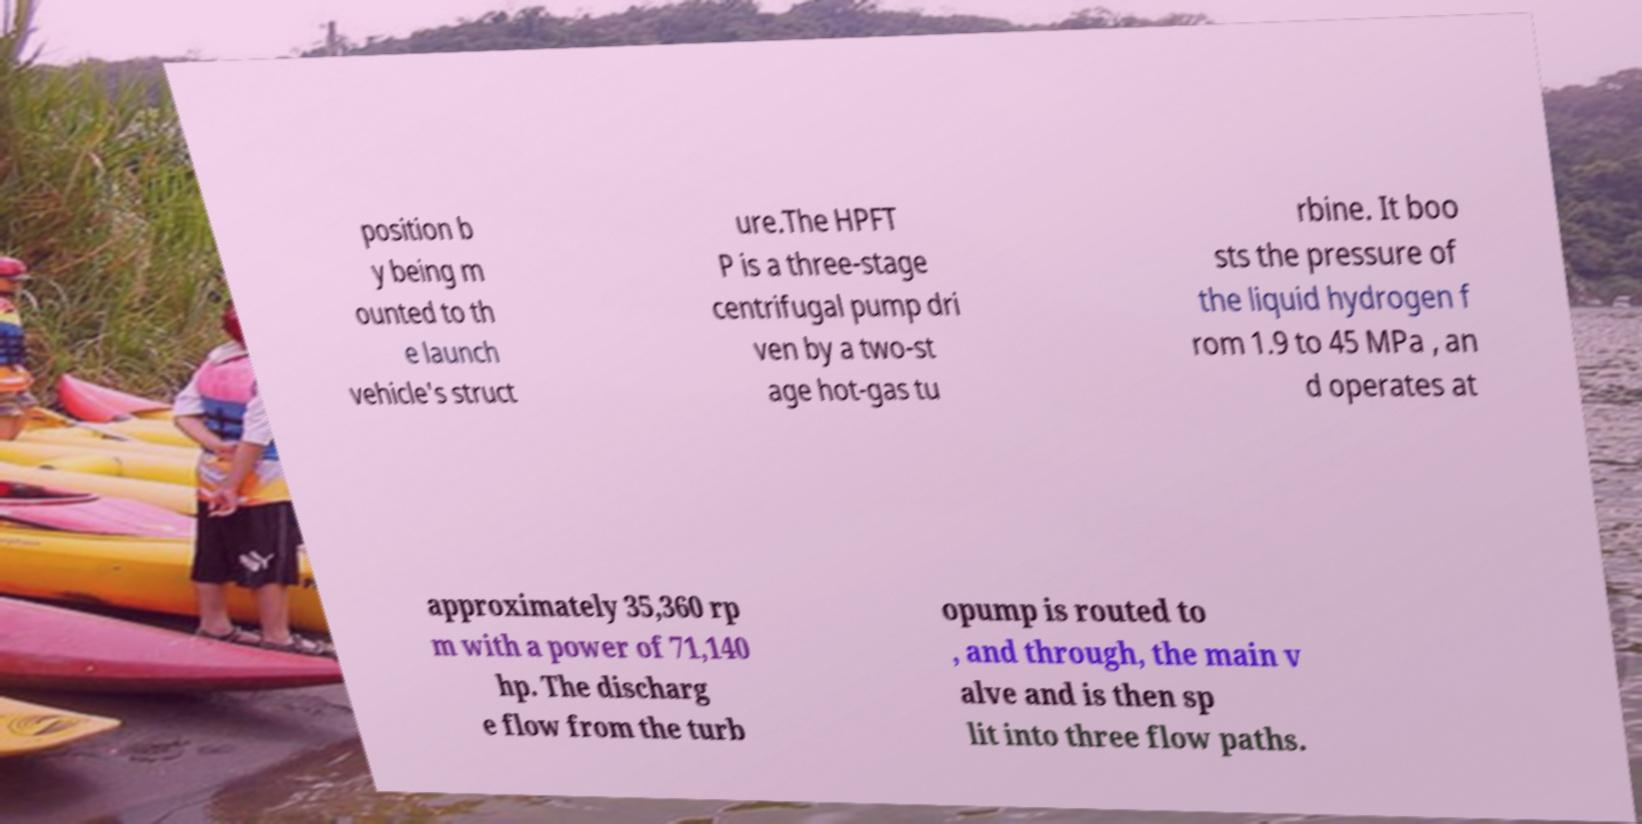Please read and relay the text visible in this image. What does it say? position b y being m ounted to th e launch vehicle's struct ure.The HPFT P is a three-stage centrifugal pump dri ven by a two-st age hot-gas tu rbine. It boo sts the pressure of the liquid hydrogen f rom 1.9 to 45 MPa , an d operates at approximately 35,360 rp m with a power of 71,140 hp. The discharg e flow from the turb opump is routed to , and through, the main v alve and is then sp lit into three flow paths. 